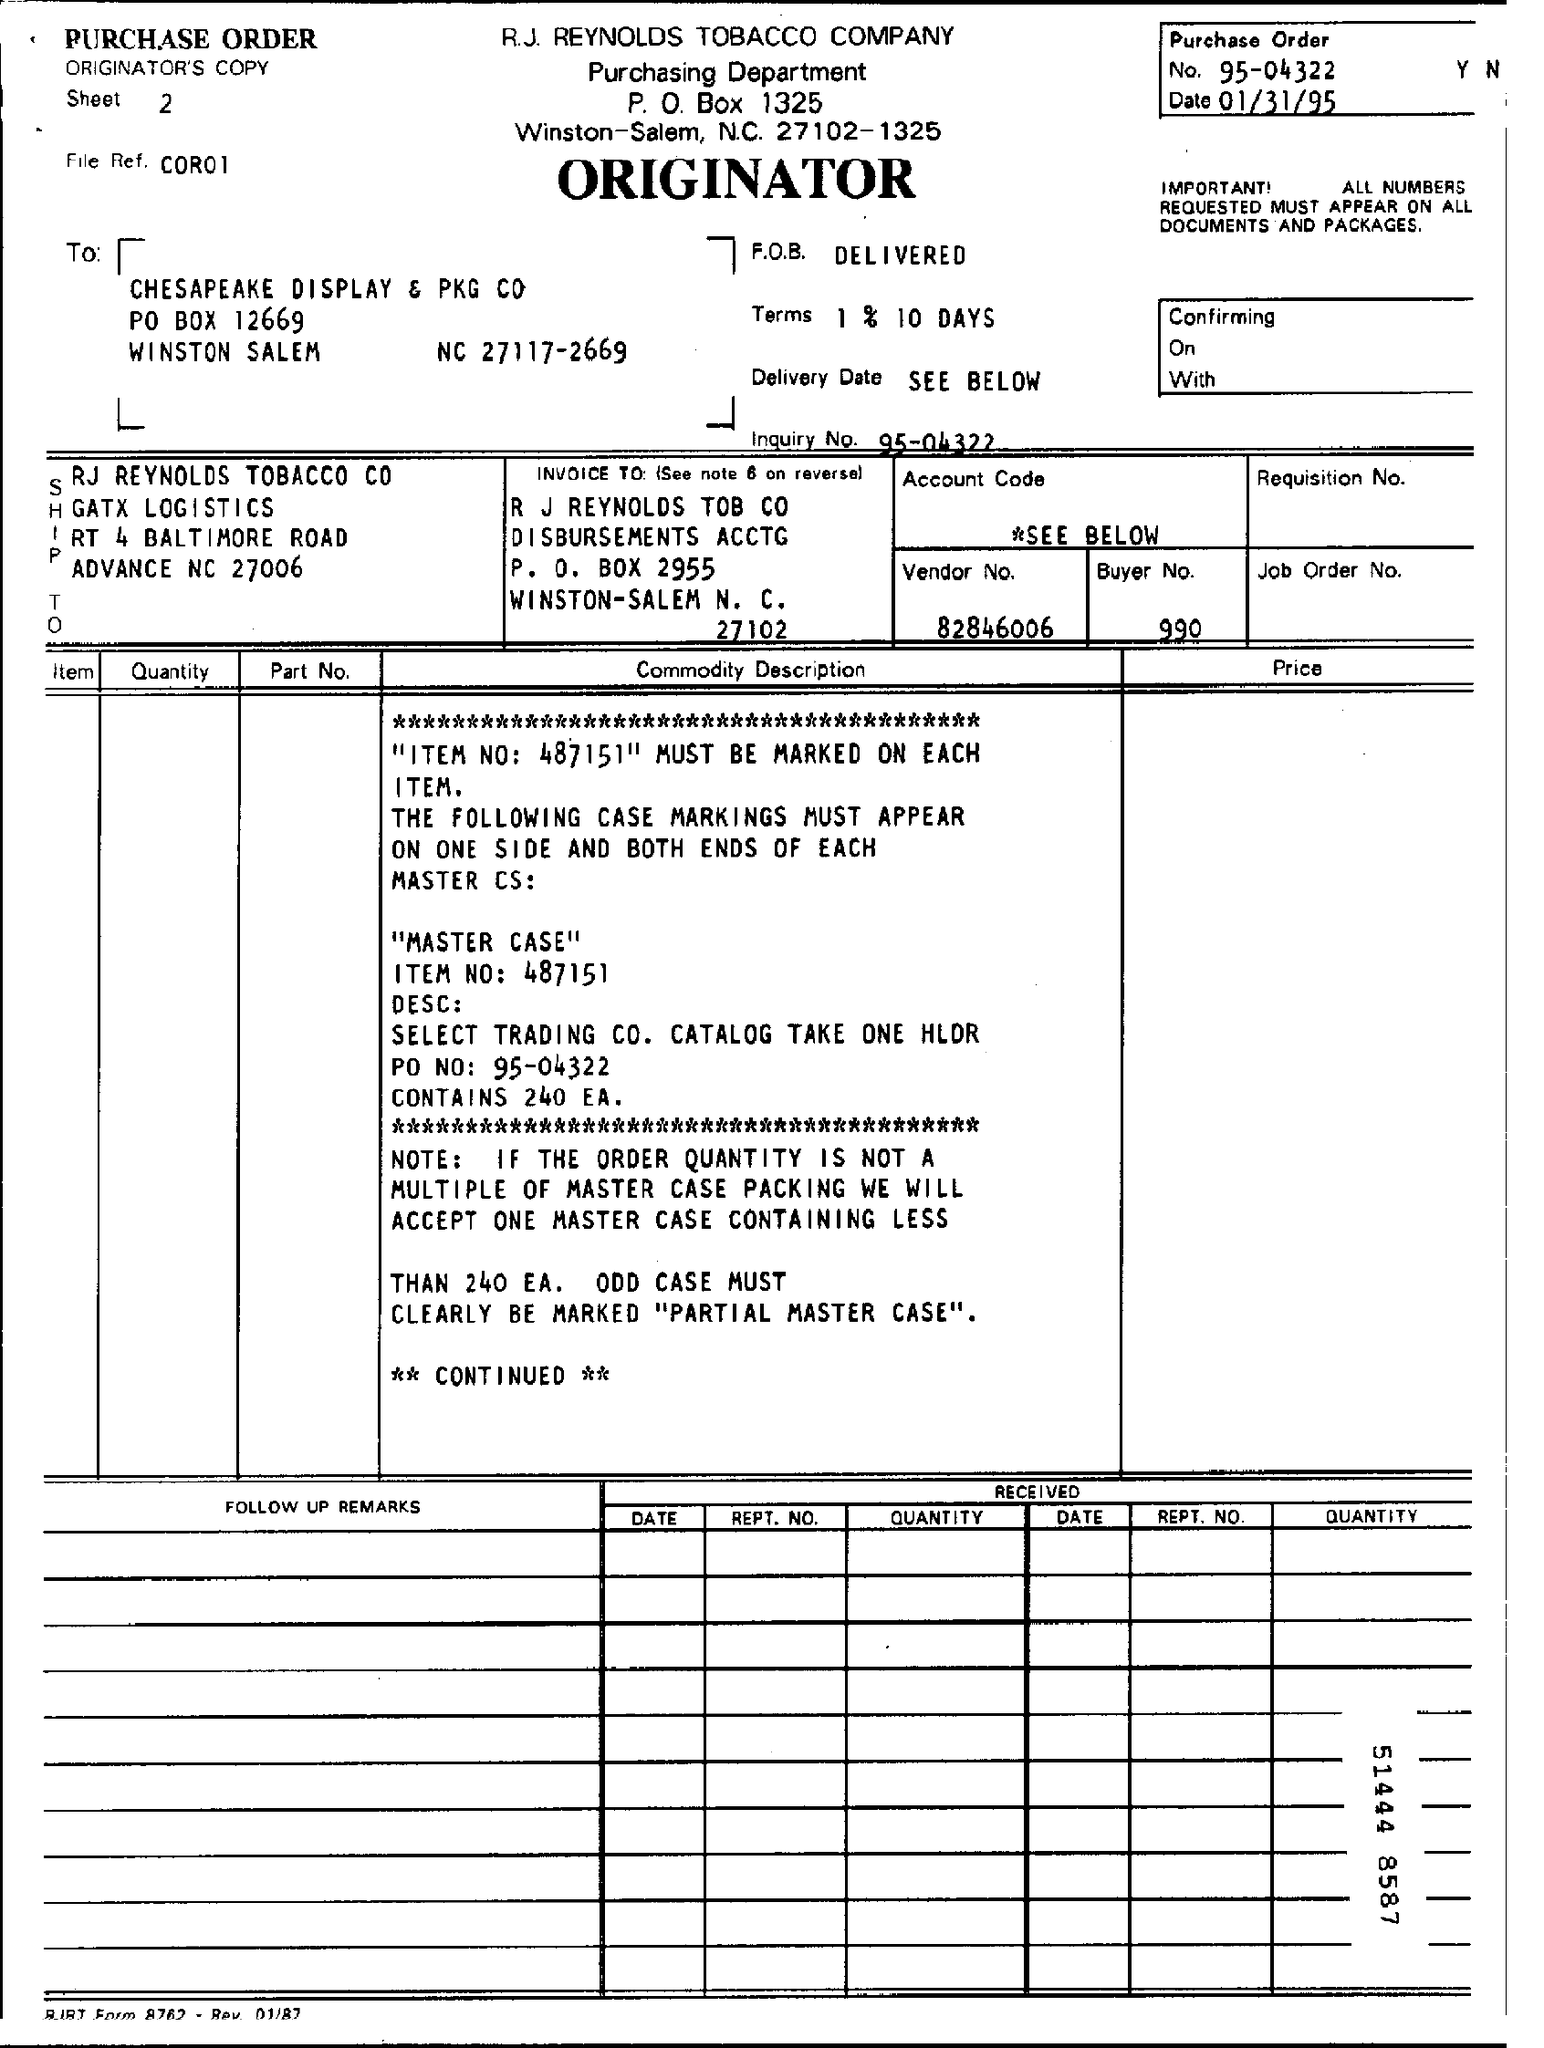Indicate a few pertinent items in this graphic. The Purchase Order date is January 31, 1995. The vendor number is 82846006... The inquiry number is 95-04322... What is the File Reference? C0R01, . The purchase order number is 95-04322. 